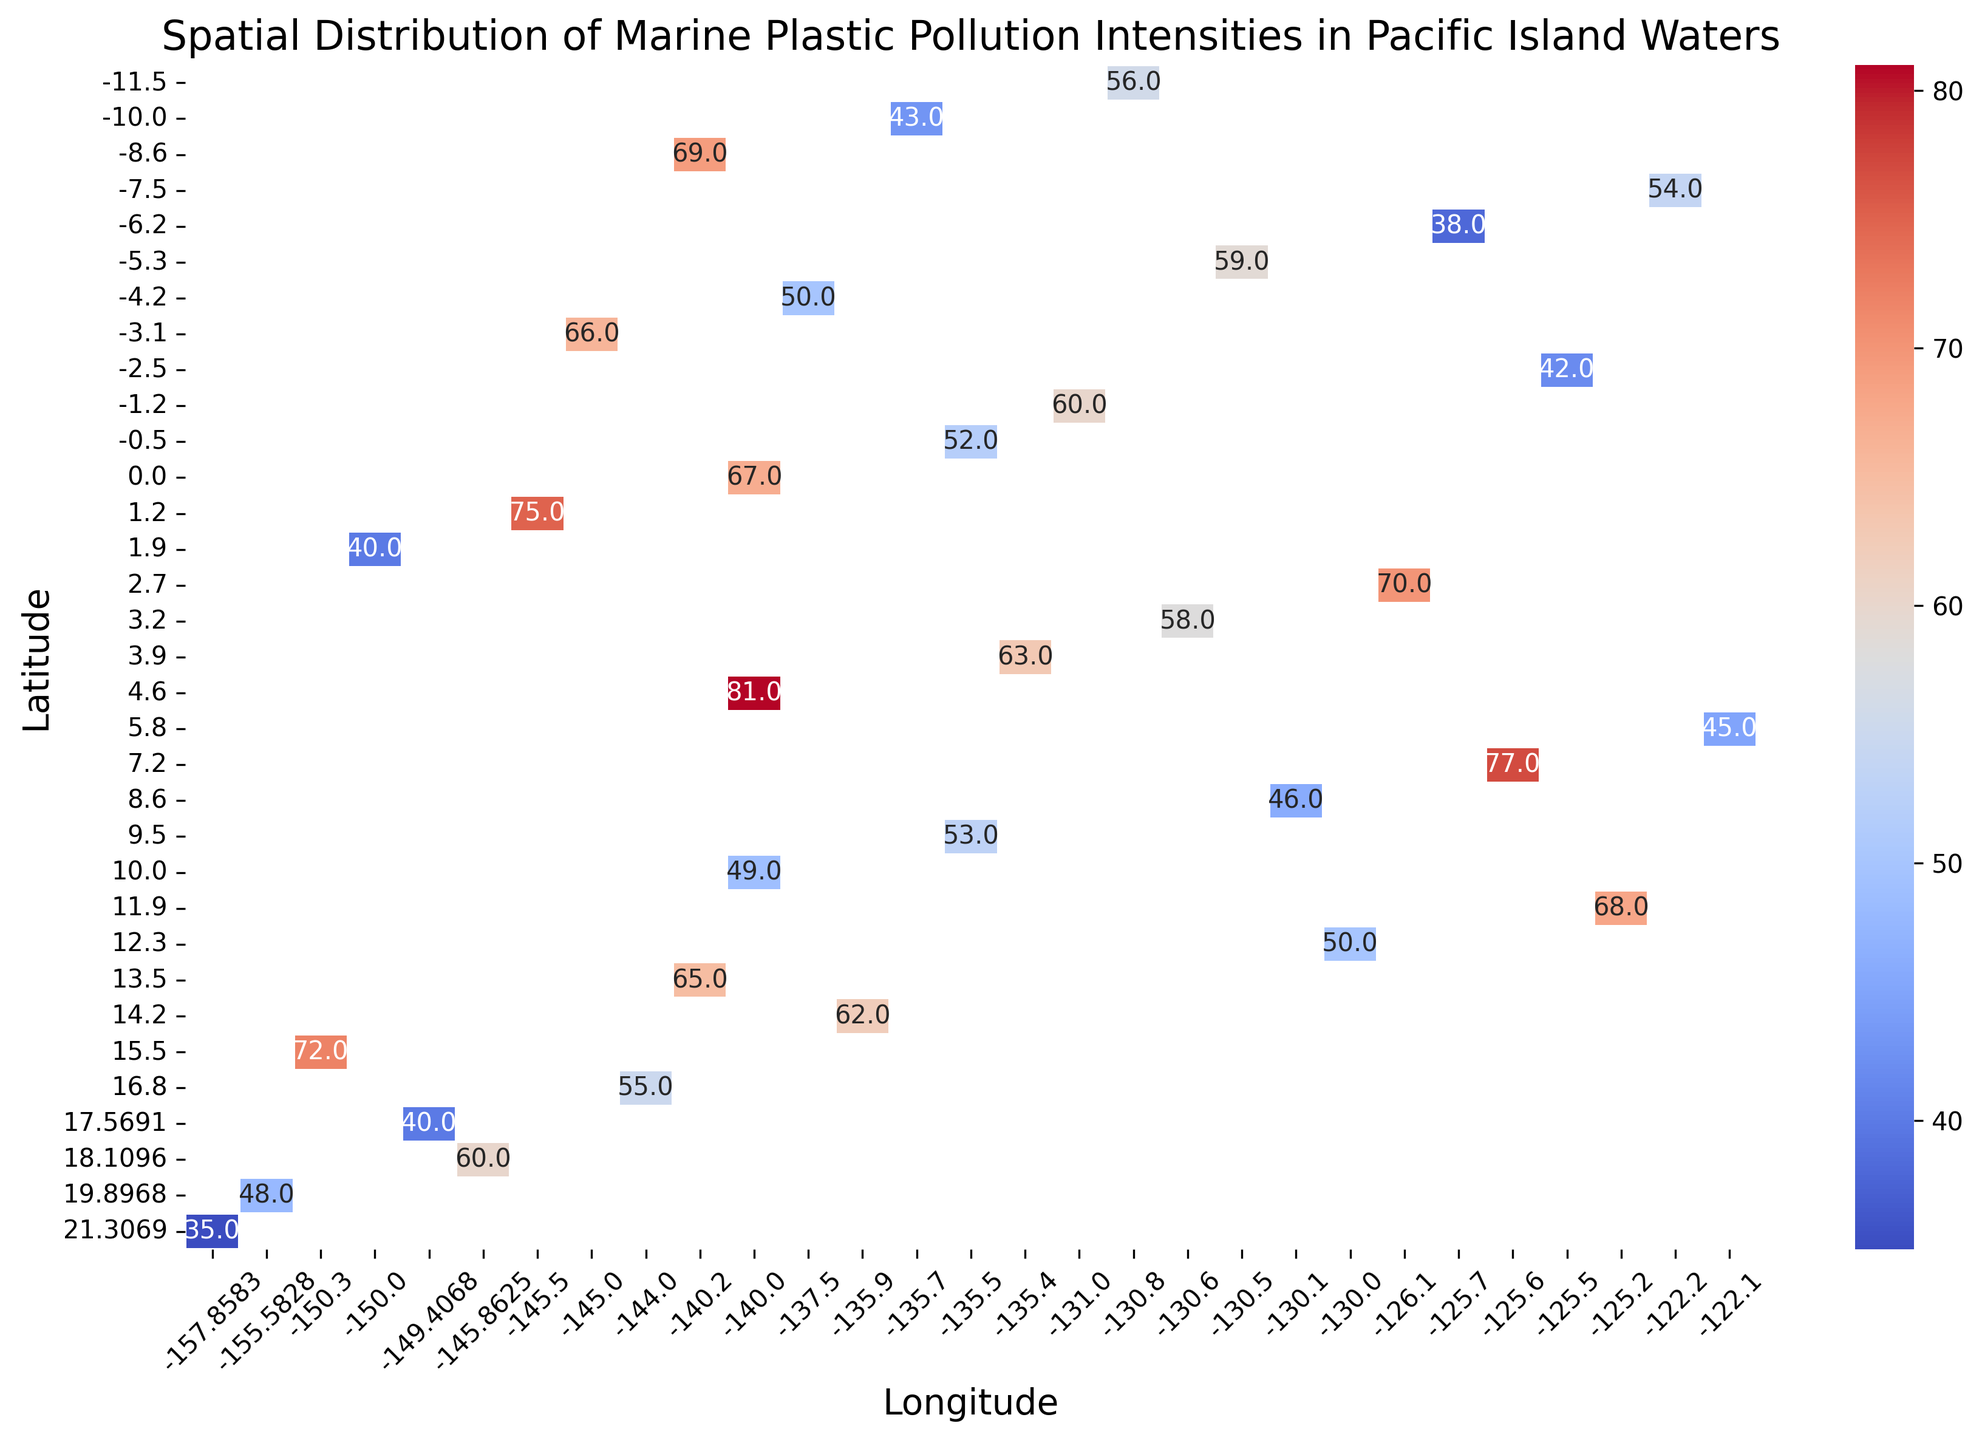What is the highest intensity value in the heatmap and at which latitude and longitude is it located? The highest intensity value can be identified by looking for the darkest or the most saturated color in the heatmap and reading the corresponding latitude and longitude coordinates. According to the heatmap, the highest intensity value is 81, located at latitude 4.6 and longitude -140.0.
Answer: 81 at (4.6, -140.0) Which latitude and longitude have the lowest intensity value, and what is that value? To find the lowest intensity value, look for the lightest or the least saturated color in the heatmap. The lowest intensity value, which is 35, is found at latitude 21.3069 and longitude -157.8583.
Answer: 35 at (21.3069, -157.8583) What is the average intensity value of the locations with latitudes greater than 10? First, identify all the intensity values corresponding to latitudes greater than 10. These intensities are 35, 48, 60, 40, 55, and 72. Summing these up gives (35 + 48 + 60 + 40 + 55 + 72) = 310. The number of values is 6, so the average intensity is 310/6 ≈ 51.7.
Answer: 51.7 Which latitude has the highest average intensity for its corresponding longitudes? To determine the highest average intensity by latitude, average the intensities for each latitude and compare them. For example, latitude 16.8000 has an intensity of 55, and latitude 4.6000 has an intensity of 81. Comparing all the averages for each latitude, the latitude 4.6000 has the highest average intensity of 81.
Answer: 4.6000 Is there a noticeable spatial trend in the intensity values as latitude decreases? Observing the heatmap visually, it is noticeable that as the latitude decreases (heading towards the equator and then into the Southern Hemisphere), the intensity values generally increase. This can be seen as the colors shift from lighter to darker shades moving downwards on the heatmap.
Answer: Yes Which longitude shows the greatest variance in intensity values across all latitudes? To find the longitude with the greatest variance, compare the spread of intensity values for each longitude. For instance, longitude -140.0 has values 49, 81, 50, etc., showing a wide range. By calculating and comparing variances, longitude -140.0 has the greatest variance due to the significant difference between the highest and lowest values.
Answer: -140.0 Which locations share the same intensity value of 60? By examining the annotated values in the heatmap, the locations (18.1096, -145.8625), (-1.2000, -131.0000), and (15.5, -150.3) share the same intensity value of 60.
Answer: (18.1096, -145.8625), (-1.2000, -131.0000), (15.5, -150.3) What is the median intensity value among all the locations shown on the heatmap? To find the median, list all intensity values in ascending order and find the middle value. The sorted list is (35, 38, 40, 40, 42, 43, 45, 46, 48, 49, 50, 50, 52, 53, 54, 55, 56, 58, 59, 60, 60, 62, 63, 65, 66, 67, 68, 69, 70, 72, 75, 77, 81). With 33 values, the median is the 17th value, which is 56.
Answer: 56 Which latitude shows the least variation in intensity values for its corresponding longitudes? For each latitude, calculate the range (max - min values). Latitude 4.6 has only one value, making the range 0, which is the least variation possible. Therefore, latitude 4.6 shows the least variation.
Answer: 4.6 